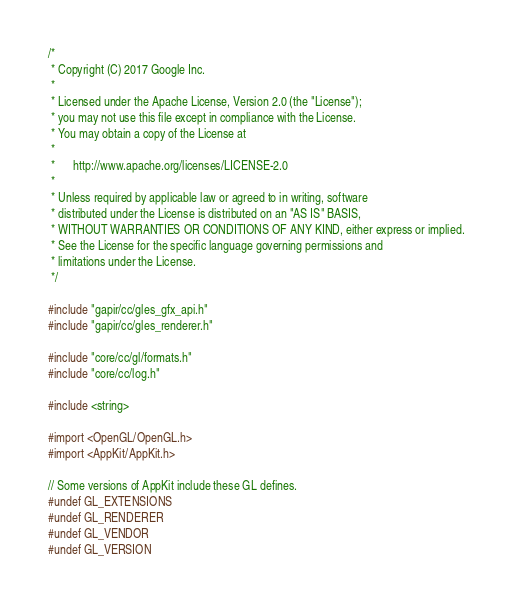Convert code to text. <code><loc_0><loc_0><loc_500><loc_500><_ObjectiveC_>/*
 * Copyright (C) 2017 Google Inc.
 *
 * Licensed under the Apache License, Version 2.0 (the "License");
 * you may not use this file except in compliance with the License.
 * You may obtain a copy of the License at
 *
 *      http://www.apache.org/licenses/LICENSE-2.0
 *
 * Unless required by applicable law or agreed to in writing, software
 * distributed under the License is distributed on an "AS IS" BASIS,
 * WITHOUT WARRANTIES OR CONDITIONS OF ANY KIND, either express or implied.
 * See the License for the specific language governing permissions and
 * limitations under the License.
 */

#include "gapir/cc/gles_gfx_api.h"
#include "gapir/cc/gles_renderer.h"

#include "core/cc/gl/formats.h"
#include "core/cc/log.h"

#include <string>

#import <OpenGL/OpenGL.h>
#import <AppKit/AppKit.h>

// Some versions of AppKit include these GL defines.
#undef GL_EXTENSIONS
#undef GL_RENDERER
#undef GL_VENDOR
#undef GL_VERSION
</code> 